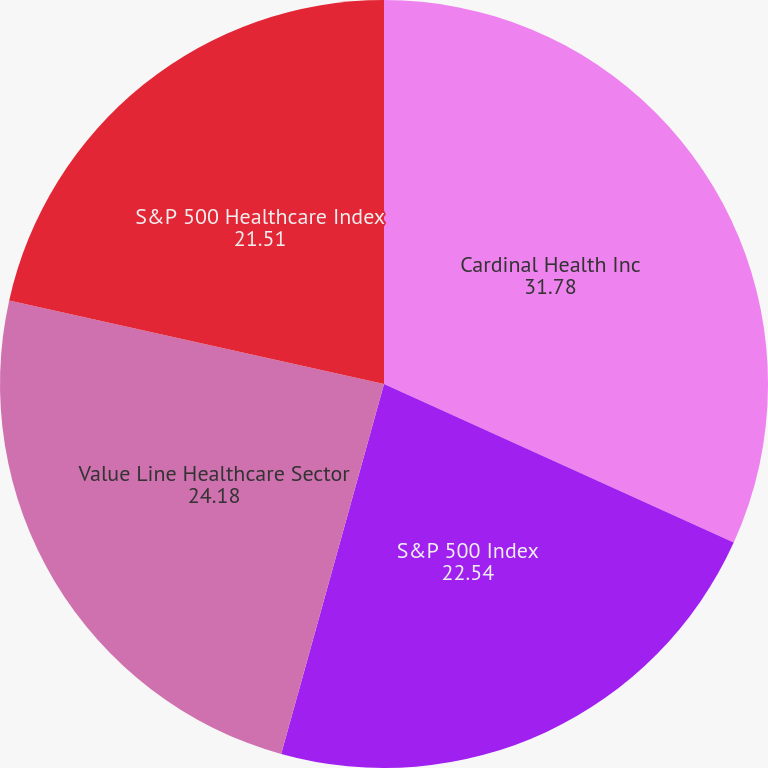Convert chart. <chart><loc_0><loc_0><loc_500><loc_500><pie_chart><fcel>Cardinal Health Inc<fcel>S&P 500 Index<fcel>Value Line Healthcare Sector<fcel>S&P 500 Healthcare Index<nl><fcel>31.78%<fcel>22.54%<fcel>24.18%<fcel>21.51%<nl></chart> 